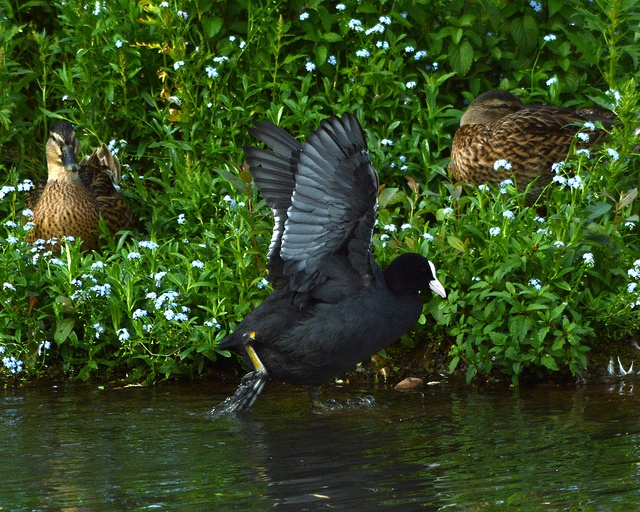Describe the objects in this image and their specific colors. I can see bird in darkgreen, black, and purple tones, bird in darkgreen, black, olive, maroon, and gray tones, and bird in darkgreen, black, olive, and tan tones in this image. 